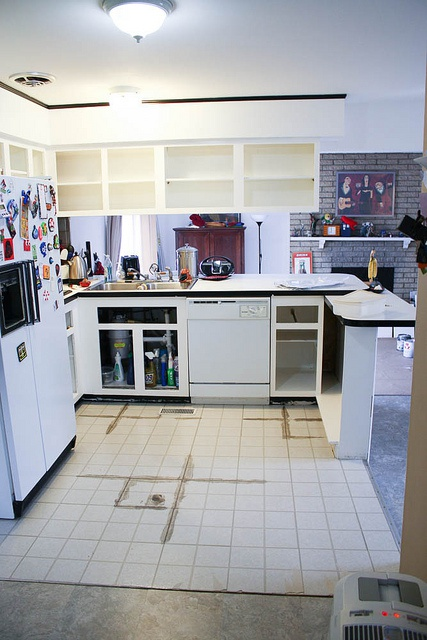Describe the objects in this image and their specific colors. I can see refrigerator in gray, lavender, black, and darkgray tones, sink in gray, tan, darkgray, and lightgray tones, bottle in gray, darkgray, and teal tones, bottle in gray, black, darkgreen, and darkgray tones, and bottle in gray, lightblue, and blue tones in this image. 